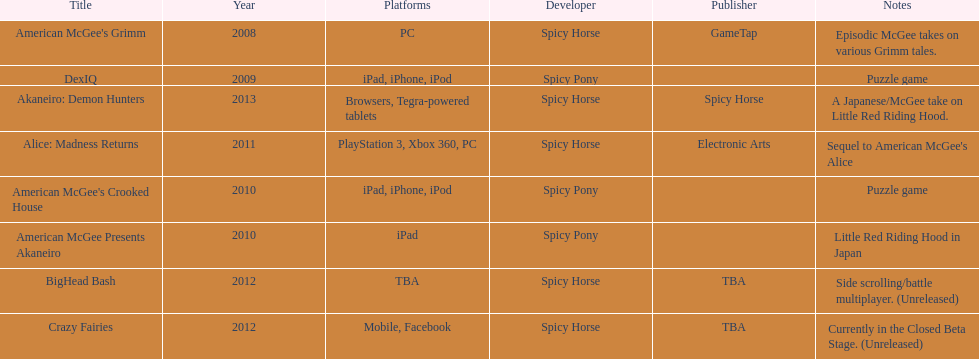What platform was used for the last title on this chart? Browsers, Tegra-powered tablets. Help me parse the entirety of this table. {'header': ['Title', 'Year', 'Platforms', 'Developer', 'Publisher', 'Notes'], 'rows': [["American McGee's Grimm", '2008', 'PC', 'Spicy Horse', 'GameTap', 'Episodic McGee takes on various Grimm tales.'], ['DexIQ', '2009', 'iPad, iPhone, iPod', 'Spicy Pony', '', 'Puzzle game'], ['Akaneiro: Demon Hunters', '2013', 'Browsers, Tegra-powered tablets', 'Spicy Horse', 'Spicy Horse', 'A Japanese/McGee take on Little Red Riding Hood.'], ['Alice: Madness Returns', '2011', 'PlayStation 3, Xbox 360, PC', 'Spicy Horse', 'Electronic Arts', "Sequel to American McGee's Alice"], ["American McGee's Crooked House", '2010', 'iPad, iPhone, iPod', 'Spicy Pony', '', 'Puzzle game'], ['American McGee Presents Akaneiro', '2010', 'iPad', 'Spicy Pony', '', 'Little Red Riding Hood in Japan'], ['BigHead Bash', '2012', 'TBA', 'Spicy Horse', 'TBA', 'Side scrolling/battle multiplayer. (Unreleased)'], ['Crazy Fairies', '2012', 'Mobile, Facebook', 'Spicy Horse', 'TBA', 'Currently in the Closed Beta Stage. (Unreleased)']]} 